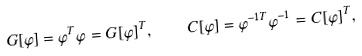Convert formula to latex. <formula><loc_0><loc_0><loc_500><loc_500>G [ \varphi ] = \varphi ^ { T } \varphi = G [ \varphi ] ^ { T } , \quad C [ \varphi ] = \varphi ^ { - 1 T } \varphi ^ { - 1 } = C [ \varphi ] ^ { T } ,</formula> 